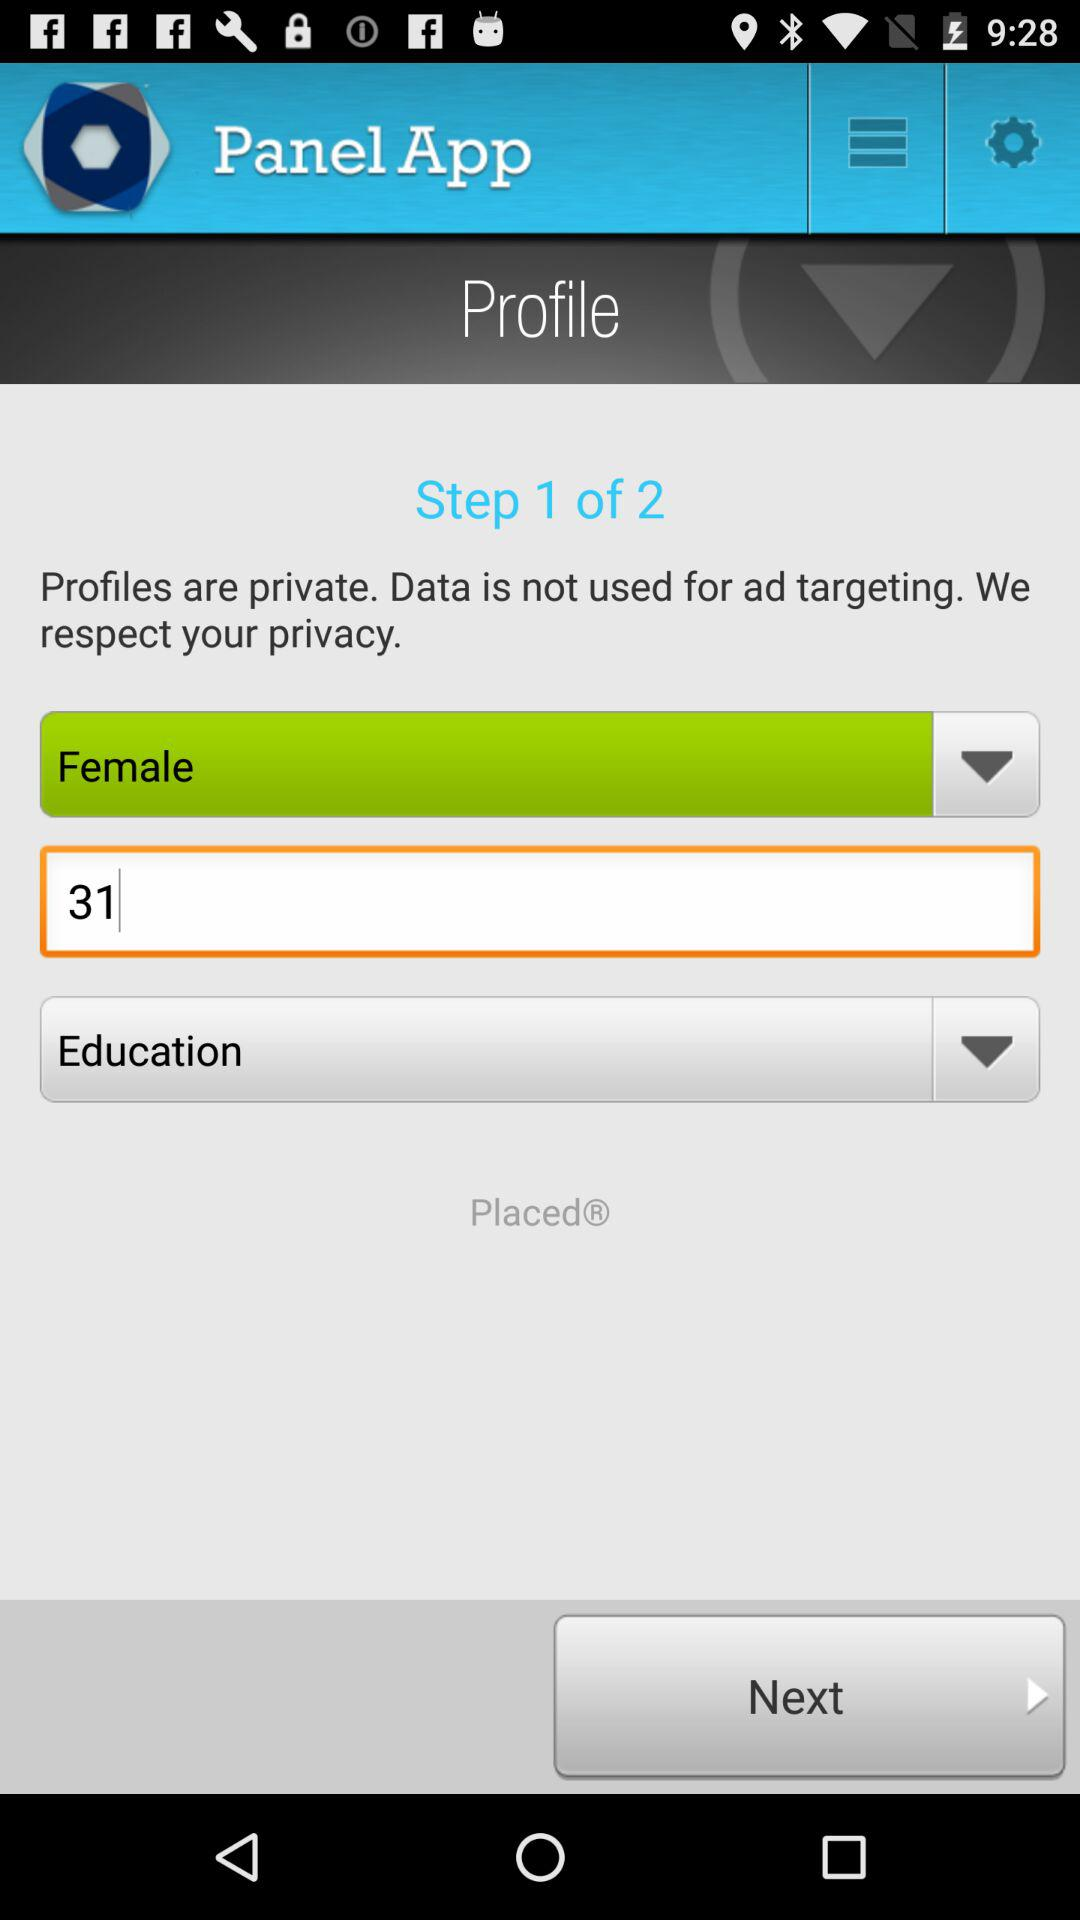What is the total number of steps? The total number of steps is 2. 